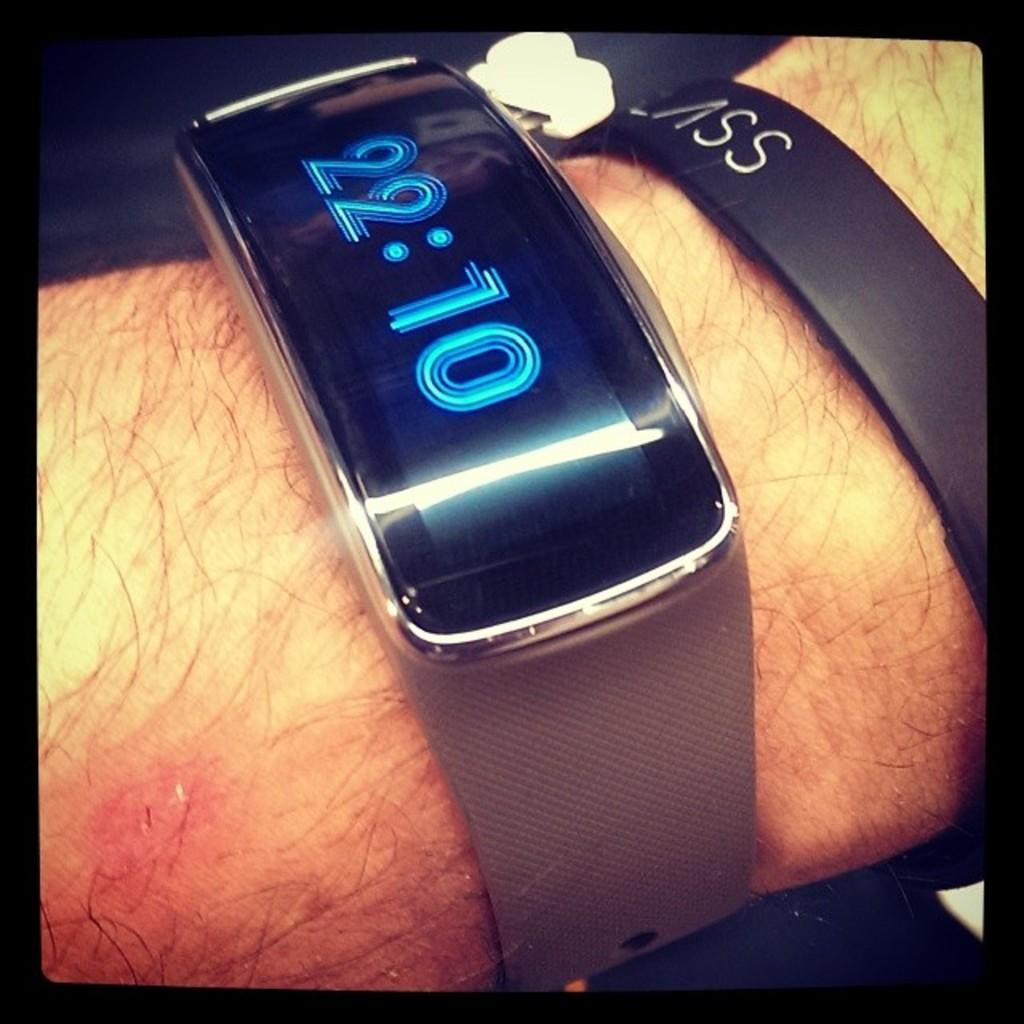<image>
Create a compact narrative representing the image presented. A person is showing a watch and a bracelet with an initial SSV on his wrist. 